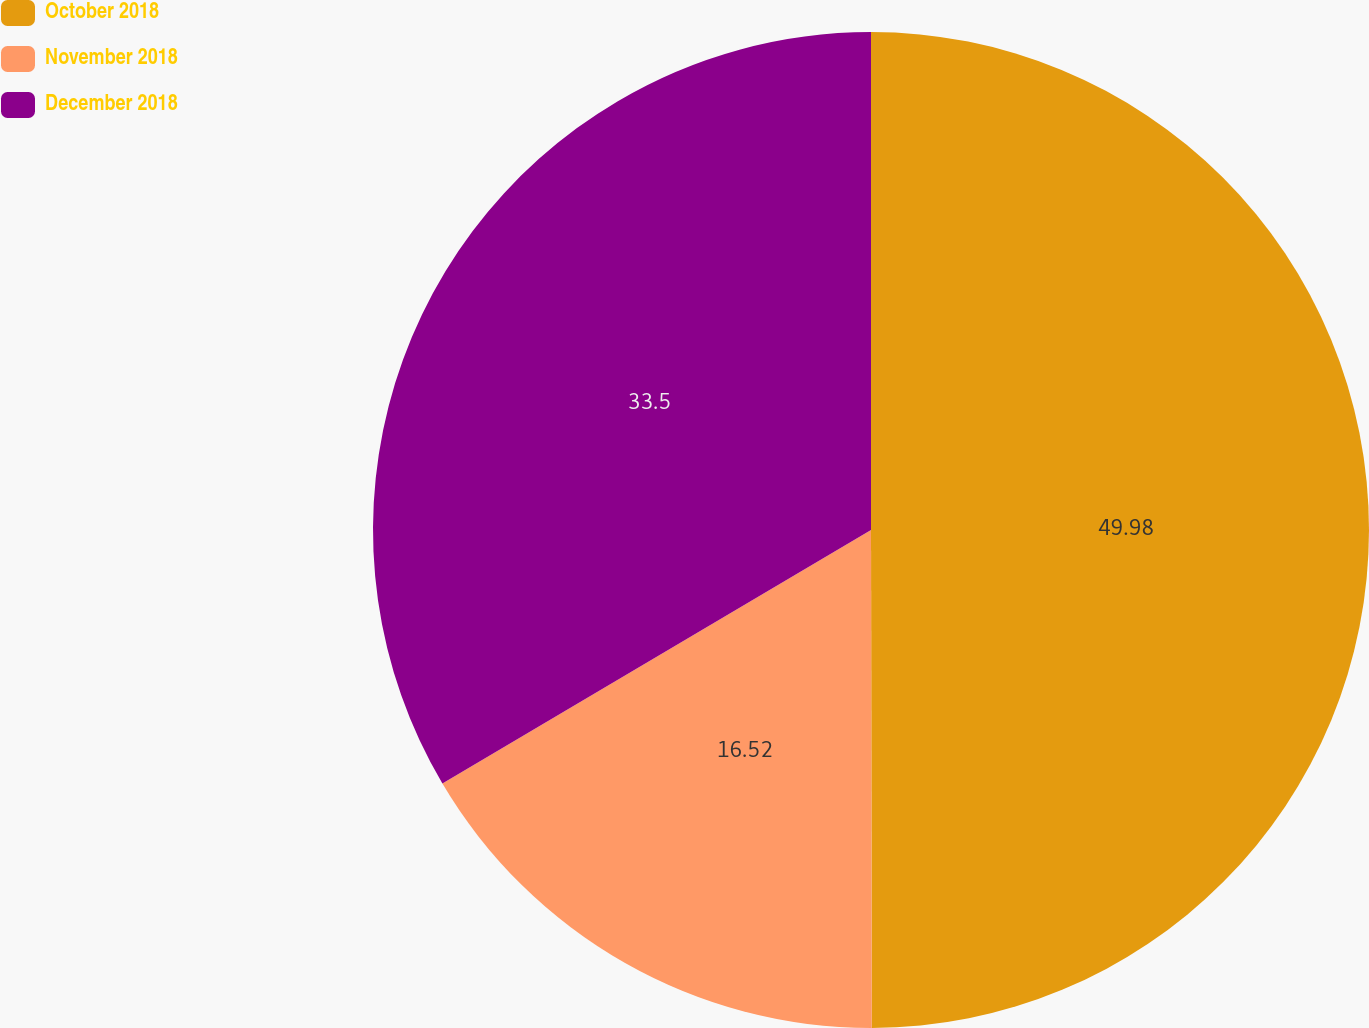<chart> <loc_0><loc_0><loc_500><loc_500><pie_chart><fcel>October 2018<fcel>November 2018<fcel>December 2018<nl><fcel>49.97%<fcel>16.52%<fcel>33.5%<nl></chart> 